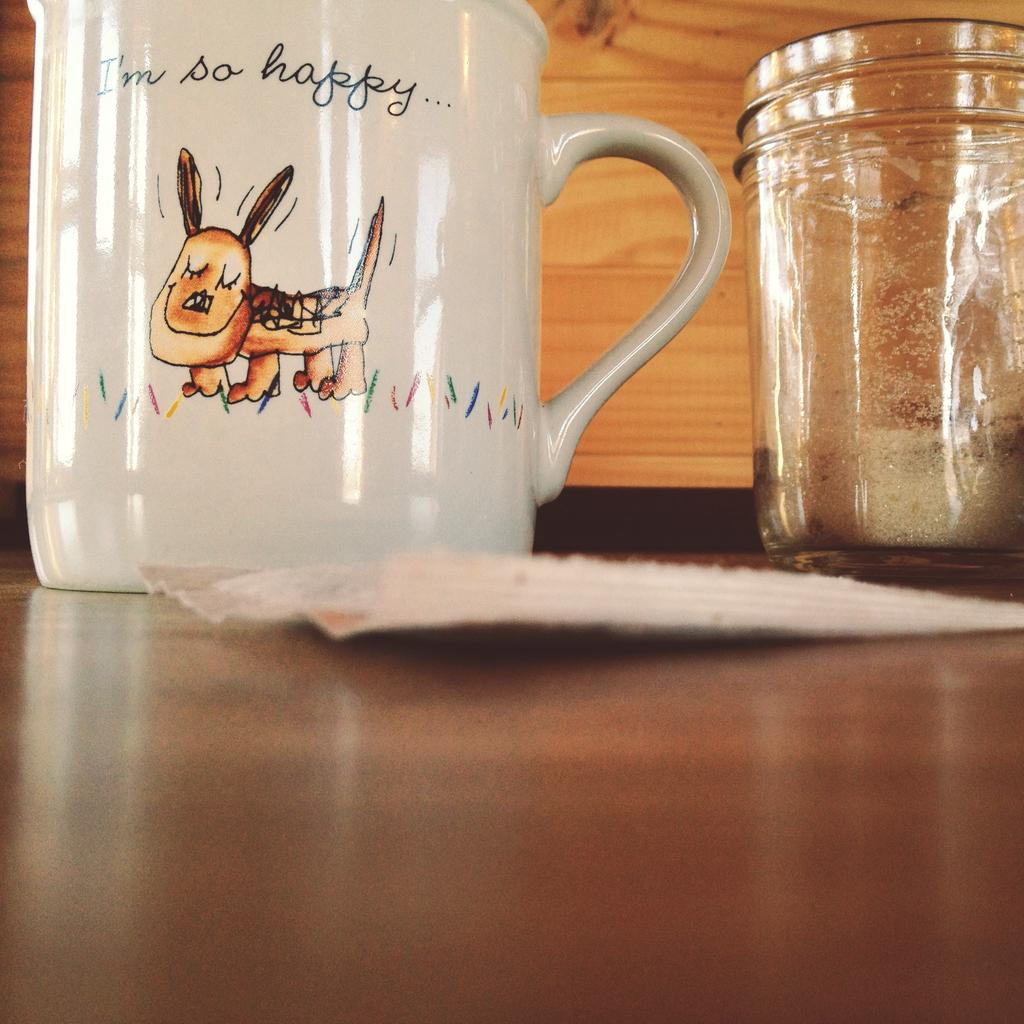What is one of the objects visible in the image? There is a jar in the image. What is another object visible in the image? There is a white-colored mug in the image. What is on the table in the image? There is a paper on the table in the image. What is depicted on the mug? The mug has a dog image on it. How many oranges are on the table in the image? There are no oranges present in the image. What type of grape is used to create the humorous effect in the image? There is no grape or humorous effect present in the image. 